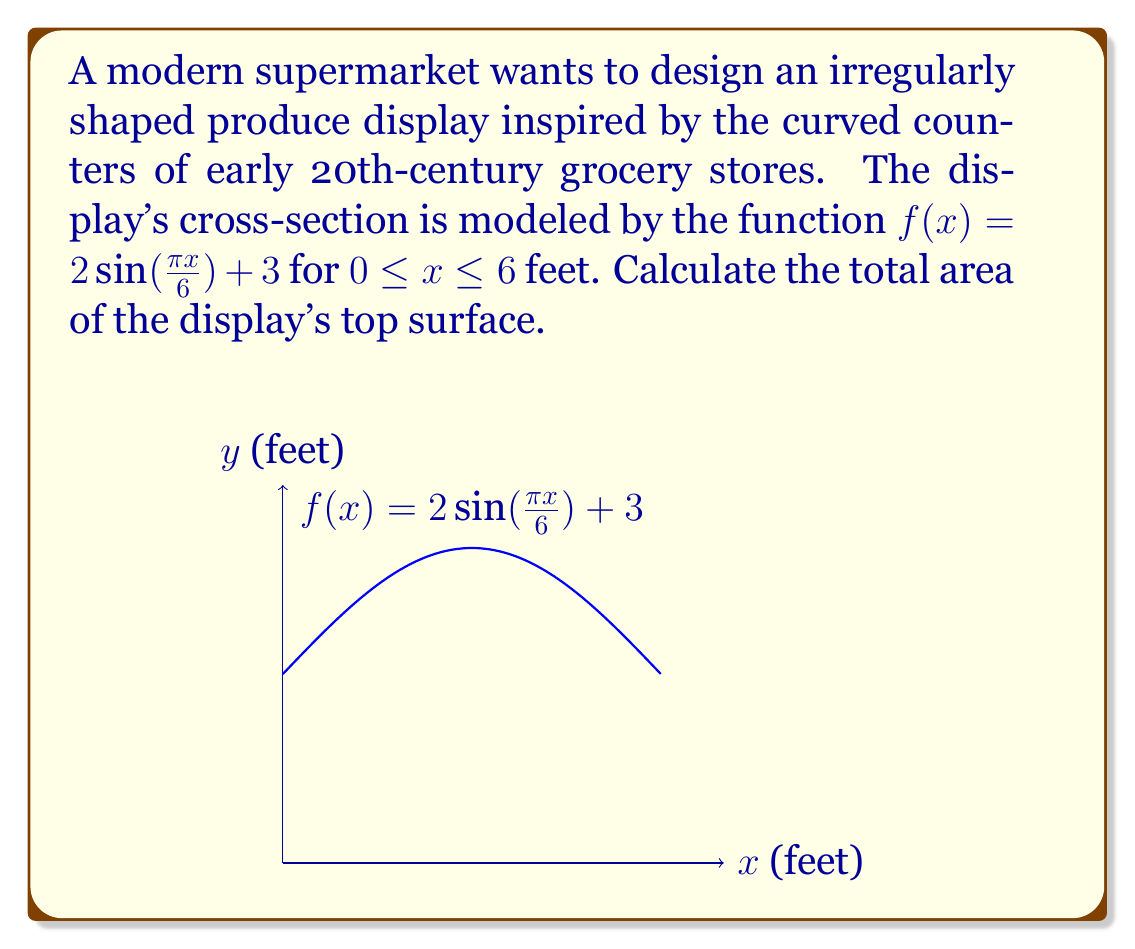Can you answer this question? To calculate the area of this irregularly shaped produce display, we need to integrate the given function over the specified interval. Here's how we do it step-by-step:

1) The area under a curve is given by the definite integral:

   $$A = \int_{a}^{b} f(x) dx$$

2) In this case, $f(x) = 2\sin(\frac{\pi x}{6}) + 3$, $a = 0$, and $b = 6$. So we have:

   $$A = \int_{0}^{6} (2\sin(\frac{\pi x}{6}) + 3) dx$$

3) We can split this into two integrals:

   $$A = \int_{0}^{6} 2\sin(\frac{\pi x}{6}) dx + \int_{0}^{6} 3 dx$$

4) For the first integral, we use the substitution $u = \frac{\pi x}{6}$, so $du = \frac{\pi}{6} dx$ or $dx = \frac{6}{\pi} du$:

   $$\int_{0}^{6} 2\sin(\frac{\pi x}{6}) dx = \frac{12}{\pi} \int_{0}^{\pi} \sin(u) du = -\frac{12}{\pi} [\cos(u)]_{0}^{\pi} = -\frac{12}{\pi} (-2) = \frac{24}{\pi}$$

5) The second integral is straightforward:

   $$\int_{0}^{6} 3 dx = [3x]_{0}^{6} = 18$$

6) Adding these results:

   $$A = \frac{24}{\pi} + 18$$

7) Simplifying:

   $$A = \frac{24}{\pi} + \frac{18\pi}{\pi} = \frac{24 + 18\pi}{\pi} \approx 25.64$$

Thus, the total area of the display's top surface is $\frac{24 + 18\pi}{\pi}$ square feet.
Answer: $\frac{24 + 18\pi}{\pi}$ sq ft 